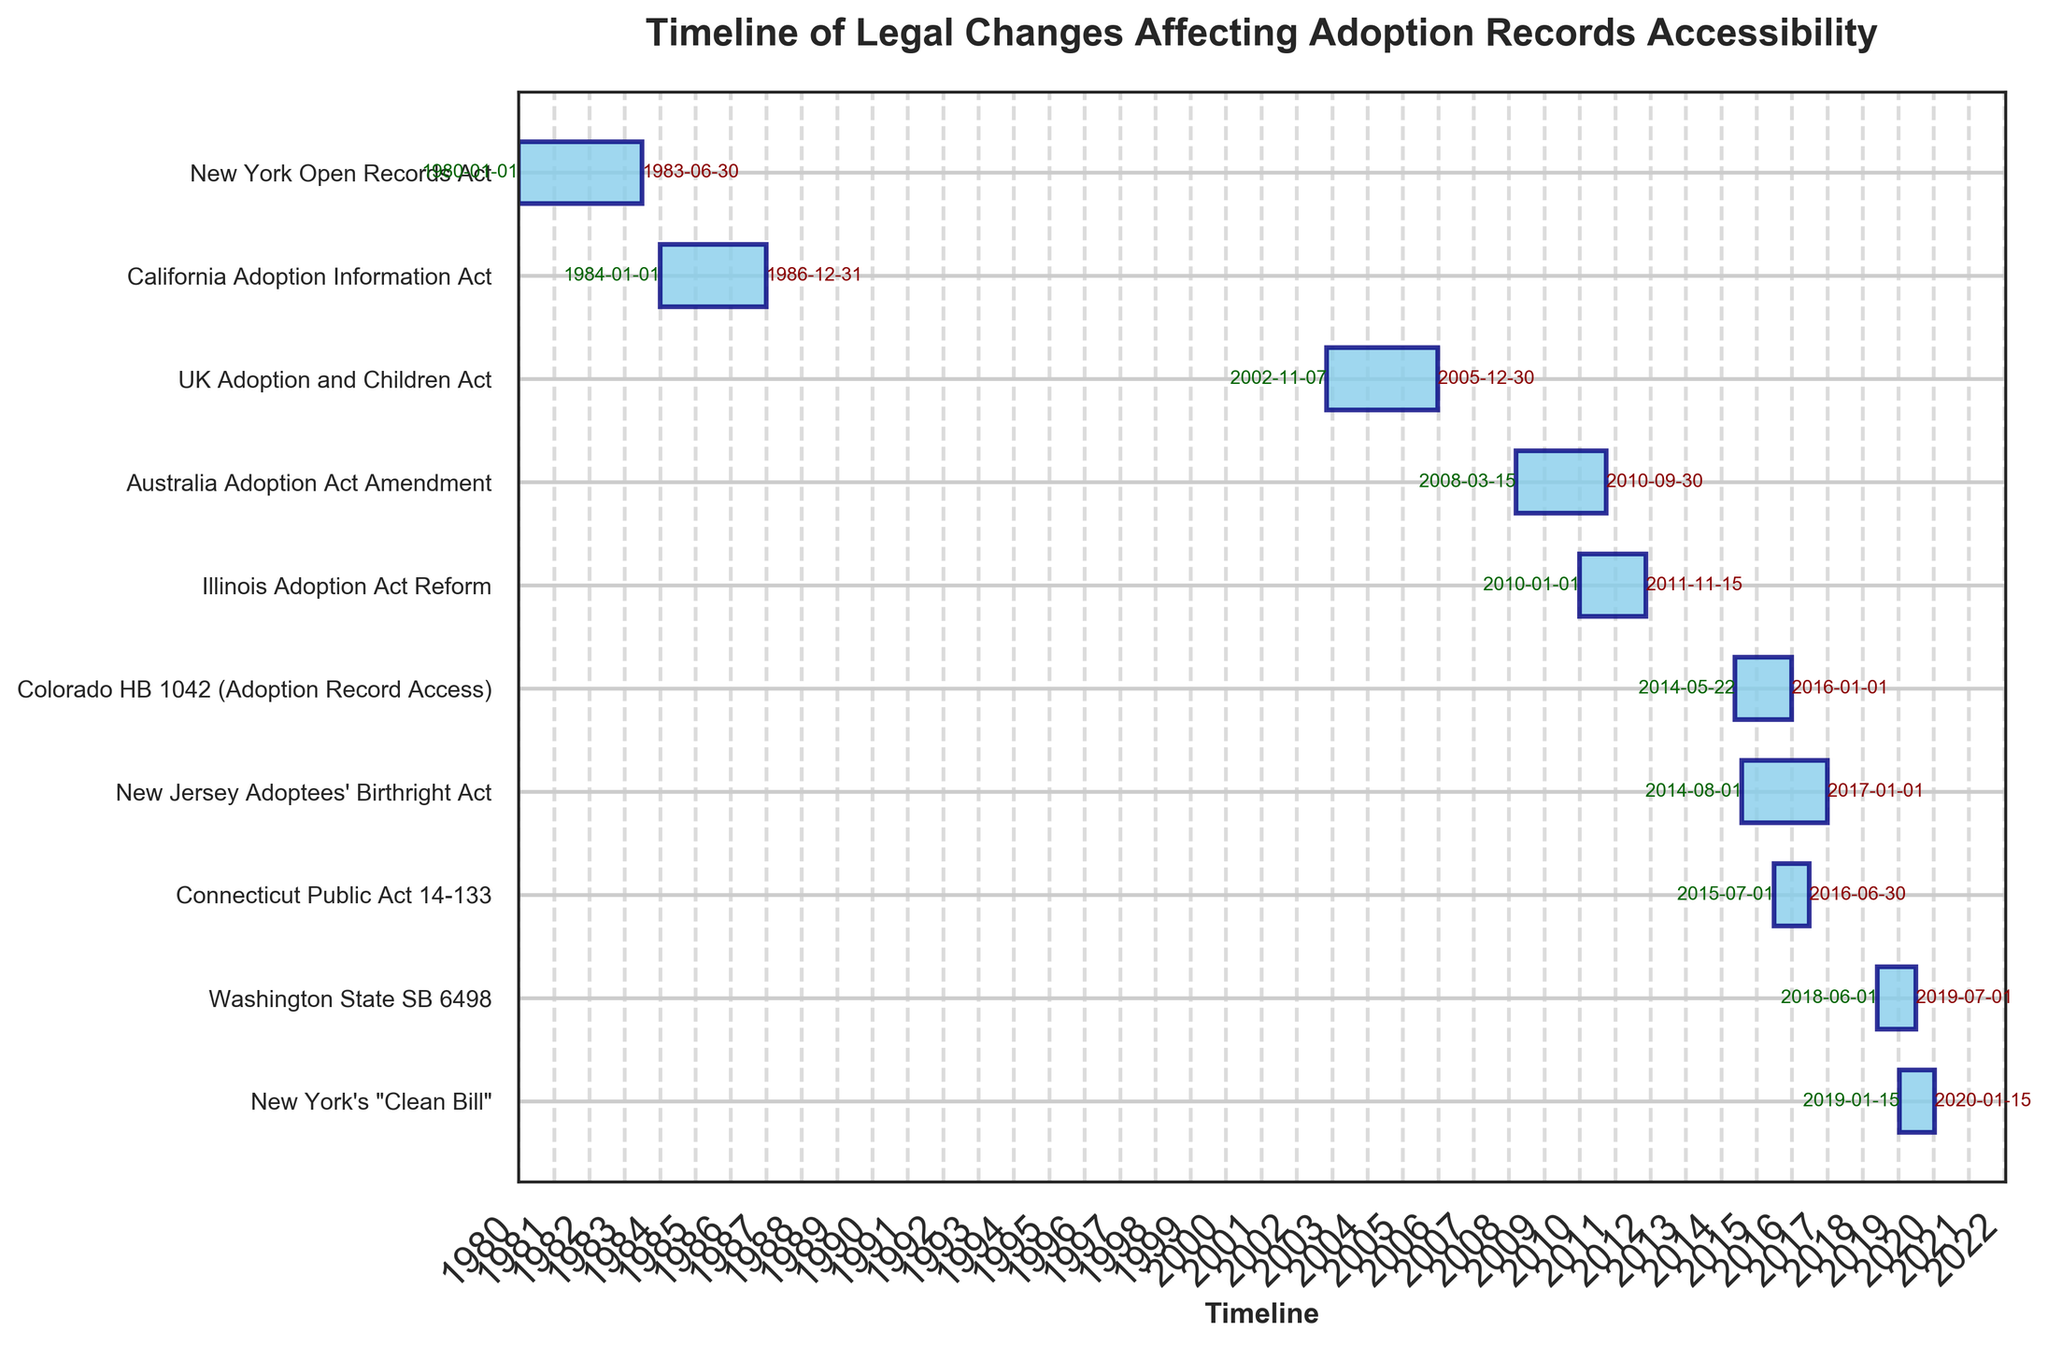What is the title of the chart? The title is written at the top of the chart and is usually bold and stands out. In this chart, it is clearly stated.
Answer: Timeline of Legal Changes Affecting Adoption Records Accessibility How many different legal changes are depicted in the chart? Count the number of horizontal bars in the chart, each representing a different legal change.
Answer: 10 Which legal change had the longest duration? Compare the length of each horizontal bar. The longest bar represents the longest duration.
Answer: New Jersey Adoptees' Birthright Act Which state or country had the most recent legal change? Look at the end dates of the bars and find the bar with the latest end date.
Answer: New York How long was the New Jersey Adoptees' Birthright Act in effect? Find the start and end dates for this act and calculate the duration between the two dates.
Answer: Approximately 2 years and 5 months What is the time span of all changes shown in the chart? Identify the earliest start date and the latest end date in the chart. Calculate the total duration between these two dates.
Answer: From 1980 to 2020 Which legal change had the shortest duration? Compare the lengths of all horizontal bars and find the shortest one.
Answer: New York's "Clean Bill" How many legal changes took place after 2010? Count the number of bars that have start dates after January 1, 2010.
Answer: 6 Which legal changes happened in the same year? Look for overlapping or very close start or end dates for different bars.
Answer: Illinois Adoption Act Reform and Connecticut Public Act 14-133 (2015) How many legal changes were in effect during 2015? Determine the number of bars that overlap the year 2015 by checking their start and end dates.
Answer: 3 